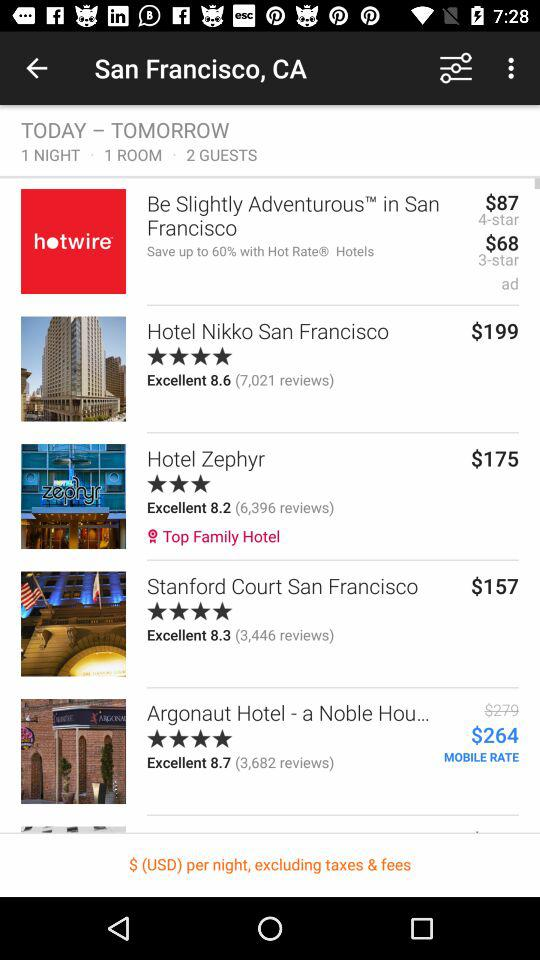What is the mentioned location? The mentioned location is San Francisco, CA. 